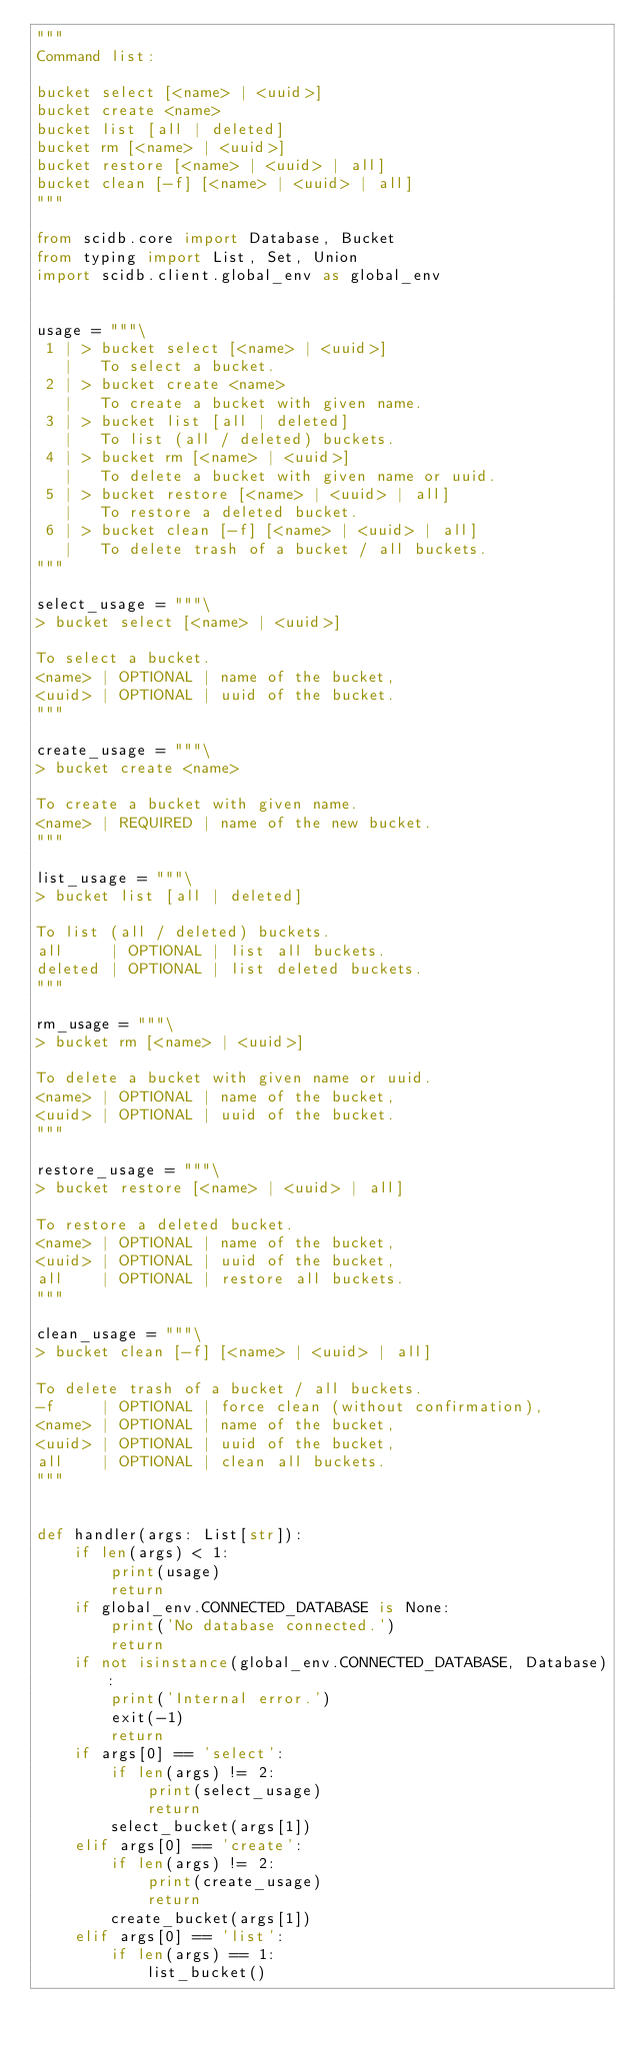<code> <loc_0><loc_0><loc_500><loc_500><_Python_>"""
Command list:

bucket select [<name> | <uuid>]
bucket create <name>
bucket list [all | deleted]
bucket rm [<name> | <uuid>]
bucket restore [<name> | <uuid> | all]
bucket clean [-f] [<name> | <uuid> | all]
"""

from scidb.core import Database, Bucket
from typing import List, Set, Union
import scidb.client.global_env as global_env


usage = """\
 1 | > bucket select [<name> | <uuid>]
   |   To select a bucket.
 2 | > bucket create <name>
   |   To create a bucket with given name.
 3 | > bucket list [all | deleted]
   |   To list (all / deleted) buckets.
 4 | > bucket rm [<name> | <uuid>]
   |   To delete a bucket with given name or uuid.
 5 | > bucket restore [<name> | <uuid> | all]
   |   To restore a deleted bucket.
 6 | > bucket clean [-f] [<name> | <uuid> | all]
   |   To delete trash of a bucket / all buckets.
"""

select_usage = """\
> bucket select [<name> | <uuid>]

To select a bucket.
<name> | OPTIONAL | name of the bucket,
<uuid> | OPTIONAL | uuid of the bucket.
"""

create_usage = """\
> bucket create <name>

To create a bucket with given name.
<name> | REQUIRED | name of the new bucket.
"""

list_usage = """\
> bucket list [all | deleted]

To list (all / deleted) buckets.
all     | OPTIONAL | list all buckets.
deleted | OPTIONAL | list deleted buckets.
"""

rm_usage = """\
> bucket rm [<name> | <uuid>]

To delete a bucket with given name or uuid.
<name> | OPTIONAL | name of the bucket,
<uuid> | OPTIONAL | uuid of the bucket.
"""

restore_usage = """\
> bucket restore [<name> | <uuid> | all]

To restore a deleted bucket.
<name> | OPTIONAL | name of the bucket,
<uuid> | OPTIONAL | uuid of the bucket,
all    | OPTIONAL | restore all buckets.
"""

clean_usage = """\
> bucket clean [-f] [<name> | <uuid> | all]

To delete trash of a bucket / all buckets.
-f     | OPTIONAL | force clean (without confirmation),
<name> | OPTIONAL | name of the bucket,
<uuid> | OPTIONAL | uuid of the bucket,
all    | OPTIONAL | clean all buckets.
"""


def handler(args: List[str]):
    if len(args) < 1:
        print(usage)
        return
    if global_env.CONNECTED_DATABASE is None:
        print('No database connected.')
        return
    if not isinstance(global_env.CONNECTED_DATABASE, Database):
        print('Internal error.')
        exit(-1)
        return
    if args[0] == 'select':
        if len(args) != 2:
            print(select_usage)
            return
        select_bucket(args[1])
    elif args[0] == 'create':
        if len(args) != 2:
            print(create_usage)
            return
        create_bucket(args[1])
    elif args[0] == 'list':
        if len(args) == 1:
            list_bucket()</code> 